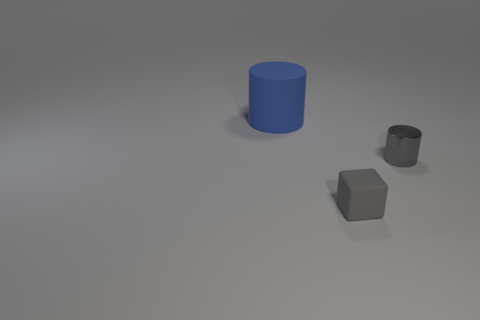Add 1 large blue metal cylinders. How many objects exist? 4 Subtract all blocks. How many objects are left? 2 Subtract all tiny green matte cylinders. Subtract all cylinders. How many objects are left? 1 Add 2 blue rubber objects. How many blue rubber objects are left? 3 Add 3 cyan matte cylinders. How many cyan matte cylinders exist? 3 Subtract 0 cyan blocks. How many objects are left? 3 